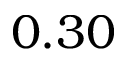<formula> <loc_0><loc_0><loc_500><loc_500>0 . 3 0</formula> 